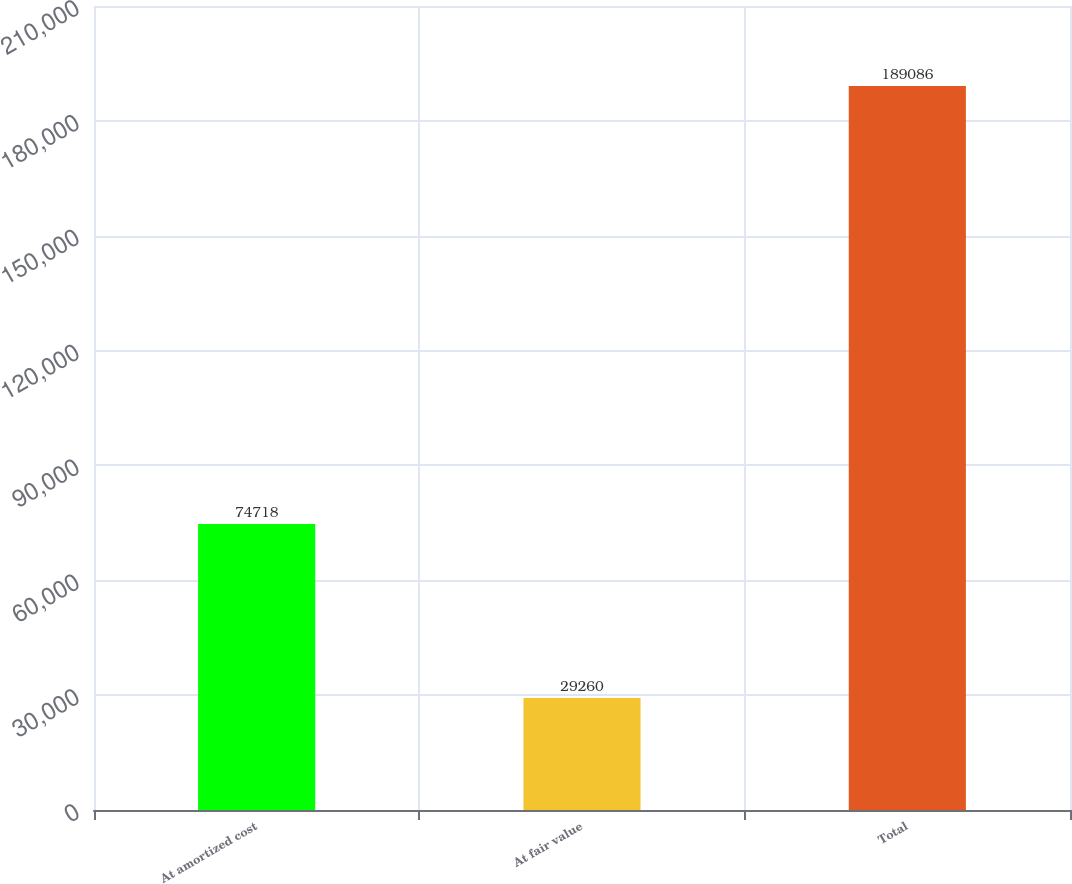Convert chart. <chart><loc_0><loc_0><loc_500><loc_500><bar_chart><fcel>At amortized cost<fcel>At fair value<fcel>Total<nl><fcel>74718<fcel>29260<fcel>189086<nl></chart> 